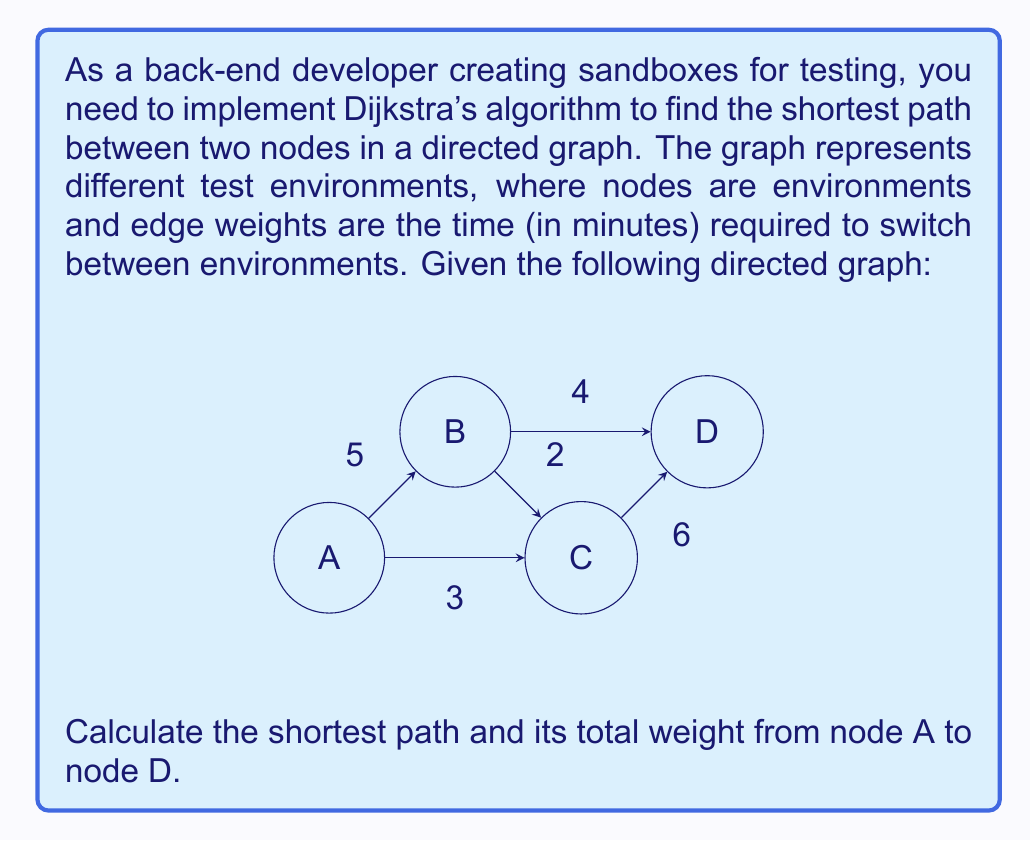Solve this math problem. To solve this problem, we'll use Dijkstra's algorithm to find the shortest path from node A to node D. Here's a step-by-step explanation:

1) Initialize distances:
   $d(A) = 0$
   $d(B) = d(C) = d(D) = \infty$

2) Initialize set of unvisited nodes: $S = \{A, B, C, D\}$

3) Start from node A:
   - Update distances to neighbors:
     $d(B) = \min(\infty, 0 + 5) = 5$
     $d(C) = \min(\infty, 0 + 3) = 3$
   - Mark A as visited: $S = \{B, C, D\}$

4) Choose the node with minimum distance (C):
   - Update distances to neighbors:
     $d(D) = \min(\infty, 3 + 6) = 9$
   - Mark C as visited: $S = \{B, D\}$

5) Choose the node with minimum distance (B):
   - Update distances to neighbors:
     $d(D) = \min(9, 5 + 4) = 9$
   - Mark B as visited: $S = \{D\}$

6) Only D remains, which is our target node. The algorithm terminates.

The shortest path from A to D is A → C → D with a total weight of 9.

To reconstruct the path, we backtrack from D:
- D's predecessor is C (via the path A → C → D with weight 9)
- C's predecessor is A (via the direct edge A → C with weight 3)

Therefore, the shortest path is A → C → D.
Answer: The shortest path from A to D is A → C → D with a total weight of 9 minutes. 